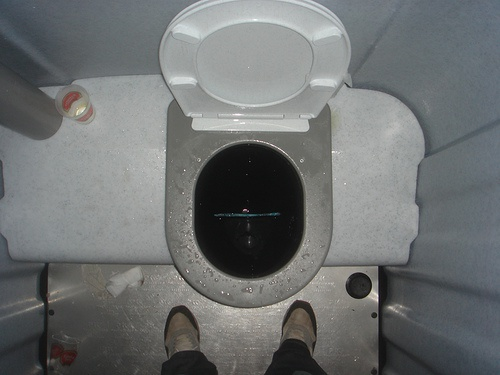Describe the objects in this image and their specific colors. I can see toilet in teal, darkgray, black, gray, and lightgray tones, people in teal, black, and gray tones, and cup in teal, gray, and darkgray tones in this image. 